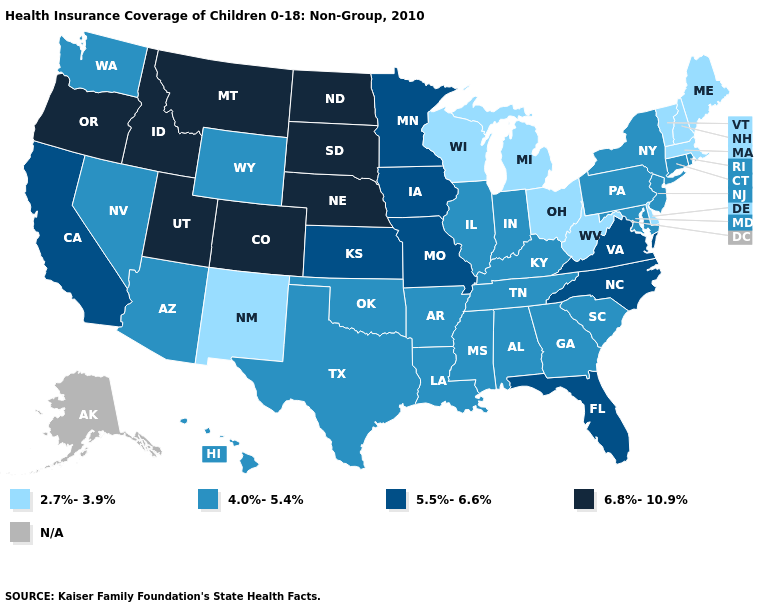Name the states that have a value in the range N/A?
Be succinct. Alaska. Does the first symbol in the legend represent the smallest category?
Answer briefly. Yes. Is the legend a continuous bar?
Keep it brief. No. What is the value of Oklahoma?
Write a very short answer. 4.0%-5.4%. What is the value of Virginia?
Answer briefly. 5.5%-6.6%. Name the states that have a value in the range 6.8%-10.9%?
Answer briefly. Colorado, Idaho, Montana, Nebraska, North Dakota, Oregon, South Dakota, Utah. What is the value of Louisiana?
Answer briefly. 4.0%-5.4%. Does Indiana have the highest value in the MidWest?
Quick response, please. No. What is the value of Kansas?
Keep it brief. 5.5%-6.6%. Does Massachusetts have the lowest value in the USA?
Give a very brief answer. Yes. Name the states that have a value in the range 6.8%-10.9%?
Answer briefly. Colorado, Idaho, Montana, Nebraska, North Dakota, Oregon, South Dakota, Utah. Name the states that have a value in the range 2.7%-3.9%?
Answer briefly. Delaware, Maine, Massachusetts, Michigan, New Hampshire, New Mexico, Ohio, Vermont, West Virginia, Wisconsin. Which states hav the highest value in the MidWest?
Concise answer only. Nebraska, North Dakota, South Dakota. Does Oklahoma have the lowest value in the South?
Short answer required. No. What is the value of Utah?
Keep it brief. 6.8%-10.9%. 